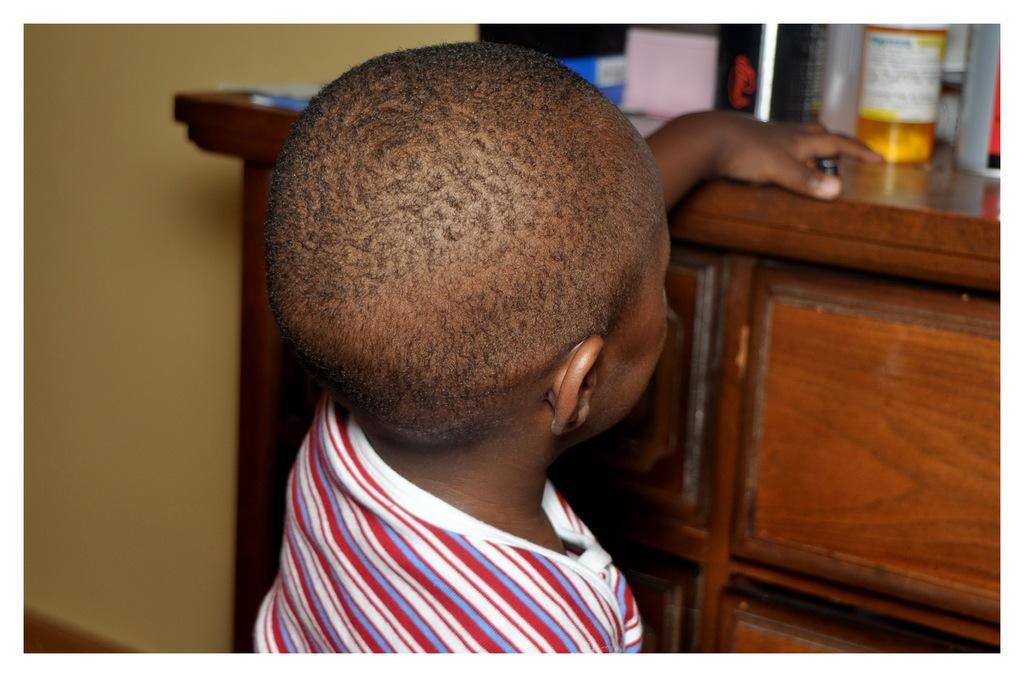Could you give a brief overview of what you see in this image? In this image we can see a child is standing, in front of him cupboard is there. On the top of the cupboard few things are kept. 